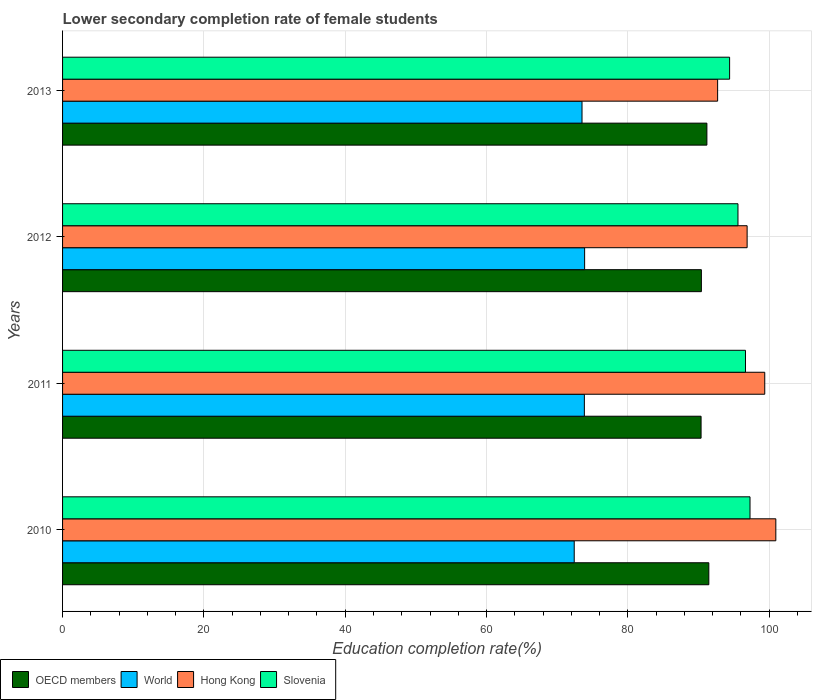How many bars are there on the 3rd tick from the bottom?
Your answer should be very brief. 4. What is the label of the 2nd group of bars from the top?
Offer a very short reply. 2012. In how many cases, is the number of bars for a given year not equal to the number of legend labels?
Ensure brevity in your answer.  0. What is the lower secondary completion rate of female students in Hong Kong in 2010?
Make the answer very short. 100.94. Across all years, what is the maximum lower secondary completion rate of female students in Hong Kong?
Offer a very short reply. 100.94. Across all years, what is the minimum lower secondary completion rate of female students in Hong Kong?
Offer a terse response. 92.71. In which year was the lower secondary completion rate of female students in Slovenia minimum?
Keep it short and to the point. 2013. What is the total lower secondary completion rate of female students in World in the graph?
Your response must be concise. 293.66. What is the difference between the lower secondary completion rate of female students in World in 2011 and that in 2013?
Your answer should be very brief. 0.33. What is the difference between the lower secondary completion rate of female students in Hong Kong in 2011 and the lower secondary completion rate of female students in World in 2013?
Your answer should be compact. 25.86. What is the average lower secondary completion rate of female students in Slovenia per year?
Your answer should be compact. 95.98. In the year 2012, what is the difference between the lower secondary completion rate of female students in World and lower secondary completion rate of female students in Hong Kong?
Offer a terse response. -23. What is the ratio of the lower secondary completion rate of female students in World in 2011 to that in 2012?
Offer a terse response. 1. Is the difference between the lower secondary completion rate of female students in World in 2010 and 2013 greater than the difference between the lower secondary completion rate of female students in Hong Kong in 2010 and 2013?
Your answer should be very brief. No. What is the difference between the highest and the second highest lower secondary completion rate of female students in World?
Provide a succinct answer. 0.04. What is the difference between the highest and the lowest lower secondary completion rate of female students in OECD members?
Offer a very short reply. 1.1. What does the 4th bar from the top in 2012 represents?
Offer a terse response. OECD members. What does the 1st bar from the bottom in 2010 represents?
Your answer should be compact. OECD members. Are all the bars in the graph horizontal?
Provide a succinct answer. Yes. How many years are there in the graph?
Your answer should be very brief. 4. What is the difference between two consecutive major ticks on the X-axis?
Your answer should be compact. 20. Are the values on the major ticks of X-axis written in scientific E-notation?
Provide a succinct answer. No. How are the legend labels stacked?
Your answer should be compact. Horizontal. What is the title of the graph?
Give a very brief answer. Lower secondary completion rate of female students. Does "Senegal" appear as one of the legend labels in the graph?
Keep it short and to the point. No. What is the label or title of the X-axis?
Give a very brief answer. Education completion rate(%). What is the label or title of the Y-axis?
Ensure brevity in your answer.  Years. What is the Education completion rate(%) in OECD members in 2010?
Make the answer very short. 91.46. What is the Education completion rate(%) in World in 2010?
Ensure brevity in your answer.  72.41. What is the Education completion rate(%) in Hong Kong in 2010?
Keep it short and to the point. 100.94. What is the Education completion rate(%) in Slovenia in 2010?
Provide a succinct answer. 97.29. What is the Education completion rate(%) of OECD members in 2011?
Offer a very short reply. 90.36. What is the Education completion rate(%) in World in 2011?
Provide a succinct answer. 73.85. What is the Education completion rate(%) of Hong Kong in 2011?
Offer a terse response. 99.38. What is the Education completion rate(%) in Slovenia in 2011?
Your answer should be compact. 96.65. What is the Education completion rate(%) in OECD members in 2012?
Make the answer very short. 90.41. What is the Education completion rate(%) of World in 2012?
Provide a short and direct response. 73.88. What is the Education completion rate(%) in Hong Kong in 2012?
Keep it short and to the point. 96.88. What is the Education completion rate(%) of Slovenia in 2012?
Your response must be concise. 95.59. What is the Education completion rate(%) of OECD members in 2013?
Keep it short and to the point. 91.19. What is the Education completion rate(%) of World in 2013?
Ensure brevity in your answer.  73.51. What is the Education completion rate(%) in Hong Kong in 2013?
Offer a very short reply. 92.71. What is the Education completion rate(%) in Slovenia in 2013?
Provide a short and direct response. 94.4. Across all years, what is the maximum Education completion rate(%) of OECD members?
Make the answer very short. 91.46. Across all years, what is the maximum Education completion rate(%) in World?
Ensure brevity in your answer.  73.88. Across all years, what is the maximum Education completion rate(%) in Hong Kong?
Keep it short and to the point. 100.94. Across all years, what is the maximum Education completion rate(%) in Slovenia?
Your response must be concise. 97.29. Across all years, what is the minimum Education completion rate(%) of OECD members?
Give a very brief answer. 90.36. Across all years, what is the minimum Education completion rate(%) of World?
Make the answer very short. 72.41. Across all years, what is the minimum Education completion rate(%) in Hong Kong?
Give a very brief answer. 92.71. Across all years, what is the minimum Education completion rate(%) in Slovenia?
Your answer should be compact. 94.4. What is the total Education completion rate(%) in OECD members in the graph?
Provide a succinct answer. 363.42. What is the total Education completion rate(%) of World in the graph?
Provide a short and direct response. 293.66. What is the total Education completion rate(%) of Hong Kong in the graph?
Offer a terse response. 389.91. What is the total Education completion rate(%) of Slovenia in the graph?
Offer a terse response. 383.93. What is the difference between the Education completion rate(%) of OECD members in 2010 and that in 2011?
Your response must be concise. 1.1. What is the difference between the Education completion rate(%) in World in 2010 and that in 2011?
Your answer should be compact. -1.43. What is the difference between the Education completion rate(%) of Hong Kong in 2010 and that in 2011?
Provide a short and direct response. 1.57. What is the difference between the Education completion rate(%) in Slovenia in 2010 and that in 2011?
Provide a short and direct response. 0.64. What is the difference between the Education completion rate(%) in OECD members in 2010 and that in 2012?
Make the answer very short. 1.05. What is the difference between the Education completion rate(%) in World in 2010 and that in 2012?
Provide a short and direct response. -1.47. What is the difference between the Education completion rate(%) in Hong Kong in 2010 and that in 2012?
Your answer should be very brief. 4.06. What is the difference between the Education completion rate(%) in Slovenia in 2010 and that in 2012?
Ensure brevity in your answer.  1.71. What is the difference between the Education completion rate(%) in OECD members in 2010 and that in 2013?
Your response must be concise. 0.28. What is the difference between the Education completion rate(%) in World in 2010 and that in 2013?
Make the answer very short. -1.1. What is the difference between the Education completion rate(%) in Hong Kong in 2010 and that in 2013?
Your answer should be compact. 8.24. What is the difference between the Education completion rate(%) of Slovenia in 2010 and that in 2013?
Your answer should be very brief. 2.89. What is the difference between the Education completion rate(%) of OECD members in 2011 and that in 2012?
Ensure brevity in your answer.  -0.04. What is the difference between the Education completion rate(%) of World in 2011 and that in 2012?
Your answer should be very brief. -0.04. What is the difference between the Education completion rate(%) of Hong Kong in 2011 and that in 2012?
Offer a very short reply. 2.49. What is the difference between the Education completion rate(%) in Slovenia in 2011 and that in 2012?
Give a very brief answer. 1.06. What is the difference between the Education completion rate(%) in OECD members in 2011 and that in 2013?
Offer a terse response. -0.82. What is the difference between the Education completion rate(%) of World in 2011 and that in 2013?
Offer a terse response. 0.33. What is the difference between the Education completion rate(%) in Hong Kong in 2011 and that in 2013?
Your response must be concise. 6.67. What is the difference between the Education completion rate(%) of Slovenia in 2011 and that in 2013?
Your answer should be compact. 2.25. What is the difference between the Education completion rate(%) in OECD members in 2012 and that in 2013?
Make the answer very short. -0.78. What is the difference between the Education completion rate(%) in World in 2012 and that in 2013?
Provide a succinct answer. 0.37. What is the difference between the Education completion rate(%) of Hong Kong in 2012 and that in 2013?
Your answer should be compact. 4.18. What is the difference between the Education completion rate(%) of Slovenia in 2012 and that in 2013?
Your response must be concise. 1.18. What is the difference between the Education completion rate(%) in OECD members in 2010 and the Education completion rate(%) in World in 2011?
Provide a succinct answer. 17.62. What is the difference between the Education completion rate(%) of OECD members in 2010 and the Education completion rate(%) of Hong Kong in 2011?
Your response must be concise. -7.91. What is the difference between the Education completion rate(%) in OECD members in 2010 and the Education completion rate(%) in Slovenia in 2011?
Your response must be concise. -5.19. What is the difference between the Education completion rate(%) of World in 2010 and the Education completion rate(%) of Hong Kong in 2011?
Offer a very short reply. -26.96. What is the difference between the Education completion rate(%) in World in 2010 and the Education completion rate(%) in Slovenia in 2011?
Keep it short and to the point. -24.24. What is the difference between the Education completion rate(%) in Hong Kong in 2010 and the Education completion rate(%) in Slovenia in 2011?
Provide a short and direct response. 4.29. What is the difference between the Education completion rate(%) of OECD members in 2010 and the Education completion rate(%) of World in 2012?
Your response must be concise. 17.58. What is the difference between the Education completion rate(%) in OECD members in 2010 and the Education completion rate(%) in Hong Kong in 2012?
Your answer should be very brief. -5.42. What is the difference between the Education completion rate(%) in OECD members in 2010 and the Education completion rate(%) in Slovenia in 2012?
Keep it short and to the point. -4.12. What is the difference between the Education completion rate(%) of World in 2010 and the Education completion rate(%) of Hong Kong in 2012?
Offer a terse response. -24.47. What is the difference between the Education completion rate(%) of World in 2010 and the Education completion rate(%) of Slovenia in 2012?
Provide a succinct answer. -23.17. What is the difference between the Education completion rate(%) of Hong Kong in 2010 and the Education completion rate(%) of Slovenia in 2012?
Your response must be concise. 5.36. What is the difference between the Education completion rate(%) of OECD members in 2010 and the Education completion rate(%) of World in 2013?
Offer a terse response. 17.95. What is the difference between the Education completion rate(%) in OECD members in 2010 and the Education completion rate(%) in Hong Kong in 2013?
Your answer should be very brief. -1.24. What is the difference between the Education completion rate(%) of OECD members in 2010 and the Education completion rate(%) of Slovenia in 2013?
Provide a short and direct response. -2.94. What is the difference between the Education completion rate(%) of World in 2010 and the Education completion rate(%) of Hong Kong in 2013?
Your response must be concise. -20.29. What is the difference between the Education completion rate(%) in World in 2010 and the Education completion rate(%) in Slovenia in 2013?
Provide a short and direct response. -21.99. What is the difference between the Education completion rate(%) of Hong Kong in 2010 and the Education completion rate(%) of Slovenia in 2013?
Provide a succinct answer. 6.54. What is the difference between the Education completion rate(%) in OECD members in 2011 and the Education completion rate(%) in World in 2012?
Offer a terse response. 16.48. What is the difference between the Education completion rate(%) of OECD members in 2011 and the Education completion rate(%) of Hong Kong in 2012?
Give a very brief answer. -6.52. What is the difference between the Education completion rate(%) in OECD members in 2011 and the Education completion rate(%) in Slovenia in 2012?
Give a very brief answer. -5.22. What is the difference between the Education completion rate(%) of World in 2011 and the Education completion rate(%) of Hong Kong in 2012?
Make the answer very short. -23.04. What is the difference between the Education completion rate(%) in World in 2011 and the Education completion rate(%) in Slovenia in 2012?
Provide a succinct answer. -21.74. What is the difference between the Education completion rate(%) of Hong Kong in 2011 and the Education completion rate(%) of Slovenia in 2012?
Ensure brevity in your answer.  3.79. What is the difference between the Education completion rate(%) of OECD members in 2011 and the Education completion rate(%) of World in 2013?
Ensure brevity in your answer.  16.85. What is the difference between the Education completion rate(%) of OECD members in 2011 and the Education completion rate(%) of Hong Kong in 2013?
Your response must be concise. -2.34. What is the difference between the Education completion rate(%) of OECD members in 2011 and the Education completion rate(%) of Slovenia in 2013?
Ensure brevity in your answer.  -4.04. What is the difference between the Education completion rate(%) of World in 2011 and the Education completion rate(%) of Hong Kong in 2013?
Ensure brevity in your answer.  -18.86. What is the difference between the Education completion rate(%) of World in 2011 and the Education completion rate(%) of Slovenia in 2013?
Your response must be concise. -20.56. What is the difference between the Education completion rate(%) in Hong Kong in 2011 and the Education completion rate(%) in Slovenia in 2013?
Offer a terse response. 4.97. What is the difference between the Education completion rate(%) in OECD members in 2012 and the Education completion rate(%) in World in 2013?
Provide a short and direct response. 16.89. What is the difference between the Education completion rate(%) in OECD members in 2012 and the Education completion rate(%) in Hong Kong in 2013?
Ensure brevity in your answer.  -2.3. What is the difference between the Education completion rate(%) in OECD members in 2012 and the Education completion rate(%) in Slovenia in 2013?
Keep it short and to the point. -4. What is the difference between the Education completion rate(%) in World in 2012 and the Education completion rate(%) in Hong Kong in 2013?
Your answer should be very brief. -18.82. What is the difference between the Education completion rate(%) in World in 2012 and the Education completion rate(%) in Slovenia in 2013?
Ensure brevity in your answer.  -20.52. What is the difference between the Education completion rate(%) in Hong Kong in 2012 and the Education completion rate(%) in Slovenia in 2013?
Your answer should be compact. 2.48. What is the average Education completion rate(%) in OECD members per year?
Offer a very short reply. 90.86. What is the average Education completion rate(%) in World per year?
Your response must be concise. 73.41. What is the average Education completion rate(%) of Hong Kong per year?
Your answer should be compact. 97.48. What is the average Education completion rate(%) in Slovenia per year?
Provide a short and direct response. 95.98. In the year 2010, what is the difference between the Education completion rate(%) in OECD members and Education completion rate(%) in World?
Your answer should be very brief. 19.05. In the year 2010, what is the difference between the Education completion rate(%) of OECD members and Education completion rate(%) of Hong Kong?
Keep it short and to the point. -9.48. In the year 2010, what is the difference between the Education completion rate(%) of OECD members and Education completion rate(%) of Slovenia?
Your response must be concise. -5.83. In the year 2010, what is the difference between the Education completion rate(%) in World and Education completion rate(%) in Hong Kong?
Keep it short and to the point. -28.53. In the year 2010, what is the difference between the Education completion rate(%) in World and Education completion rate(%) in Slovenia?
Your answer should be compact. -24.88. In the year 2010, what is the difference between the Education completion rate(%) of Hong Kong and Education completion rate(%) of Slovenia?
Offer a terse response. 3.65. In the year 2011, what is the difference between the Education completion rate(%) of OECD members and Education completion rate(%) of World?
Offer a terse response. 16.52. In the year 2011, what is the difference between the Education completion rate(%) in OECD members and Education completion rate(%) in Hong Kong?
Your response must be concise. -9.01. In the year 2011, what is the difference between the Education completion rate(%) in OECD members and Education completion rate(%) in Slovenia?
Your response must be concise. -6.29. In the year 2011, what is the difference between the Education completion rate(%) in World and Education completion rate(%) in Hong Kong?
Provide a short and direct response. -25.53. In the year 2011, what is the difference between the Education completion rate(%) of World and Education completion rate(%) of Slovenia?
Keep it short and to the point. -22.8. In the year 2011, what is the difference between the Education completion rate(%) in Hong Kong and Education completion rate(%) in Slovenia?
Offer a very short reply. 2.73. In the year 2012, what is the difference between the Education completion rate(%) of OECD members and Education completion rate(%) of World?
Provide a short and direct response. 16.52. In the year 2012, what is the difference between the Education completion rate(%) of OECD members and Education completion rate(%) of Hong Kong?
Ensure brevity in your answer.  -6.47. In the year 2012, what is the difference between the Education completion rate(%) of OECD members and Education completion rate(%) of Slovenia?
Give a very brief answer. -5.18. In the year 2012, what is the difference between the Education completion rate(%) in World and Education completion rate(%) in Hong Kong?
Keep it short and to the point. -23. In the year 2012, what is the difference between the Education completion rate(%) in World and Education completion rate(%) in Slovenia?
Give a very brief answer. -21.7. In the year 2012, what is the difference between the Education completion rate(%) of Hong Kong and Education completion rate(%) of Slovenia?
Provide a succinct answer. 1.3. In the year 2013, what is the difference between the Education completion rate(%) of OECD members and Education completion rate(%) of World?
Keep it short and to the point. 17.67. In the year 2013, what is the difference between the Education completion rate(%) in OECD members and Education completion rate(%) in Hong Kong?
Offer a very short reply. -1.52. In the year 2013, what is the difference between the Education completion rate(%) of OECD members and Education completion rate(%) of Slovenia?
Offer a very short reply. -3.22. In the year 2013, what is the difference between the Education completion rate(%) of World and Education completion rate(%) of Hong Kong?
Your response must be concise. -19.19. In the year 2013, what is the difference between the Education completion rate(%) in World and Education completion rate(%) in Slovenia?
Offer a very short reply. -20.89. In the year 2013, what is the difference between the Education completion rate(%) in Hong Kong and Education completion rate(%) in Slovenia?
Give a very brief answer. -1.7. What is the ratio of the Education completion rate(%) in OECD members in 2010 to that in 2011?
Your answer should be compact. 1.01. What is the ratio of the Education completion rate(%) in World in 2010 to that in 2011?
Give a very brief answer. 0.98. What is the ratio of the Education completion rate(%) in Hong Kong in 2010 to that in 2011?
Provide a short and direct response. 1.02. What is the ratio of the Education completion rate(%) of Slovenia in 2010 to that in 2011?
Offer a terse response. 1.01. What is the ratio of the Education completion rate(%) in OECD members in 2010 to that in 2012?
Offer a very short reply. 1.01. What is the ratio of the Education completion rate(%) in World in 2010 to that in 2012?
Give a very brief answer. 0.98. What is the ratio of the Education completion rate(%) of Hong Kong in 2010 to that in 2012?
Provide a short and direct response. 1.04. What is the ratio of the Education completion rate(%) in Slovenia in 2010 to that in 2012?
Your response must be concise. 1.02. What is the ratio of the Education completion rate(%) of OECD members in 2010 to that in 2013?
Ensure brevity in your answer.  1. What is the ratio of the Education completion rate(%) in Hong Kong in 2010 to that in 2013?
Ensure brevity in your answer.  1.09. What is the ratio of the Education completion rate(%) of Slovenia in 2010 to that in 2013?
Offer a terse response. 1.03. What is the ratio of the Education completion rate(%) in World in 2011 to that in 2012?
Ensure brevity in your answer.  1. What is the ratio of the Education completion rate(%) of Hong Kong in 2011 to that in 2012?
Your answer should be very brief. 1.03. What is the ratio of the Education completion rate(%) in Slovenia in 2011 to that in 2012?
Ensure brevity in your answer.  1.01. What is the ratio of the Education completion rate(%) in OECD members in 2011 to that in 2013?
Offer a very short reply. 0.99. What is the ratio of the Education completion rate(%) of Hong Kong in 2011 to that in 2013?
Provide a succinct answer. 1.07. What is the ratio of the Education completion rate(%) in Slovenia in 2011 to that in 2013?
Make the answer very short. 1.02. What is the ratio of the Education completion rate(%) in Hong Kong in 2012 to that in 2013?
Ensure brevity in your answer.  1.04. What is the ratio of the Education completion rate(%) in Slovenia in 2012 to that in 2013?
Keep it short and to the point. 1.01. What is the difference between the highest and the second highest Education completion rate(%) in OECD members?
Your answer should be very brief. 0.28. What is the difference between the highest and the second highest Education completion rate(%) in World?
Give a very brief answer. 0.04. What is the difference between the highest and the second highest Education completion rate(%) in Hong Kong?
Offer a terse response. 1.57. What is the difference between the highest and the second highest Education completion rate(%) of Slovenia?
Your answer should be very brief. 0.64. What is the difference between the highest and the lowest Education completion rate(%) in OECD members?
Your response must be concise. 1.1. What is the difference between the highest and the lowest Education completion rate(%) of World?
Offer a terse response. 1.47. What is the difference between the highest and the lowest Education completion rate(%) in Hong Kong?
Offer a terse response. 8.24. What is the difference between the highest and the lowest Education completion rate(%) of Slovenia?
Give a very brief answer. 2.89. 